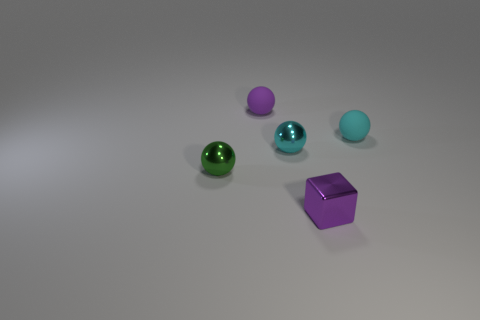Subtract all small purple rubber spheres. How many spheres are left? 3 Subtract all cyan balls. How many balls are left? 2 Subtract all spheres. How many objects are left? 1 Subtract all yellow blocks. How many cyan spheres are left? 2 Add 5 cyan rubber spheres. How many objects exist? 10 Subtract all red spheres. Subtract all cyan cylinders. How many spheres are left? 4 Add 2 cyan shiny things. How many cyan shiny things exist? 3 Subtract 0 brown balls. How many objects are left? 5 Subtract 4 balls. How many balls are left? 0 Subtract all small rubber spheres. Subtract all rubber spheres. How many objects are left? 1 